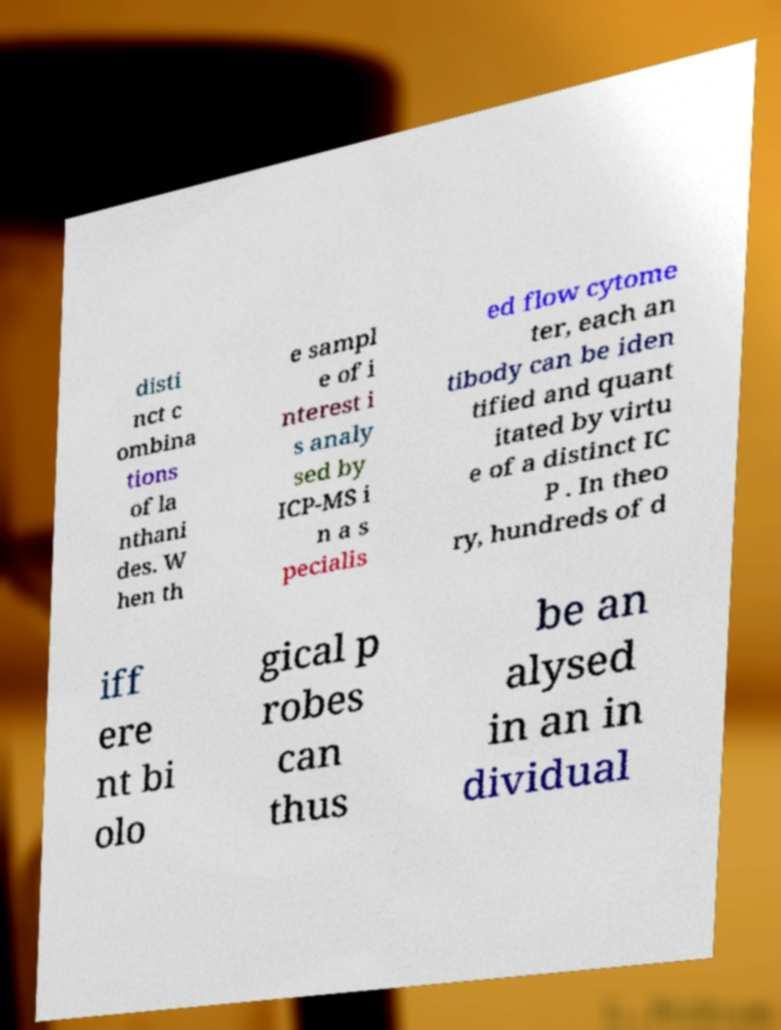What messages or text are displayed in this image? I need them in a readable, typed format. disti nct c ombina tions of la nthani des. W hen th e sampl e of i nterest i s analy sed by ICP-MS i n a s pecialis ed flow cytome ter, each an tibody can be iden tified and quant itated by virtu e of a distinct IC P . In theo ry, hundreds of d iff ere nt bi olo gical p robes can thus be an alysed in an in dividual 